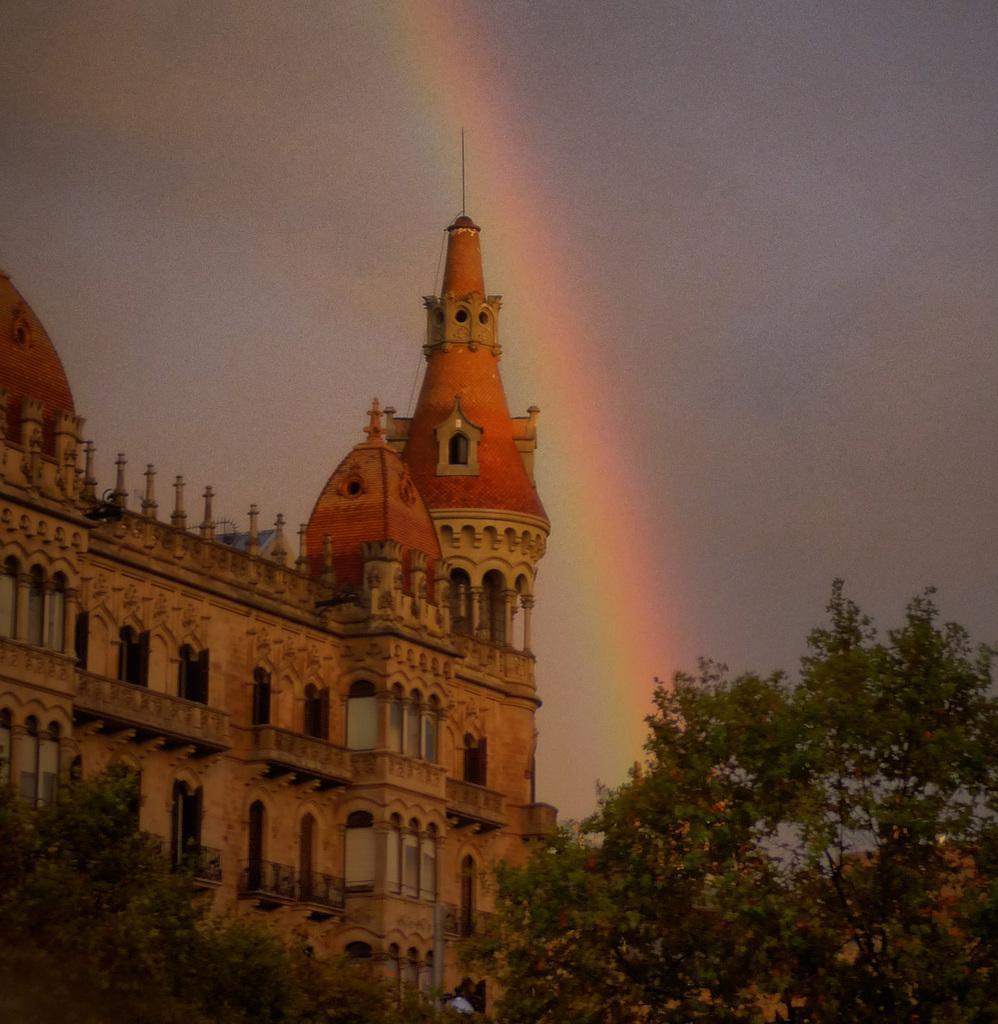How would you summarize this image in a sentence or two? In this image at the bottom we can see trees. In the background there is a building, windows, rainbow and clouds in the sky. 